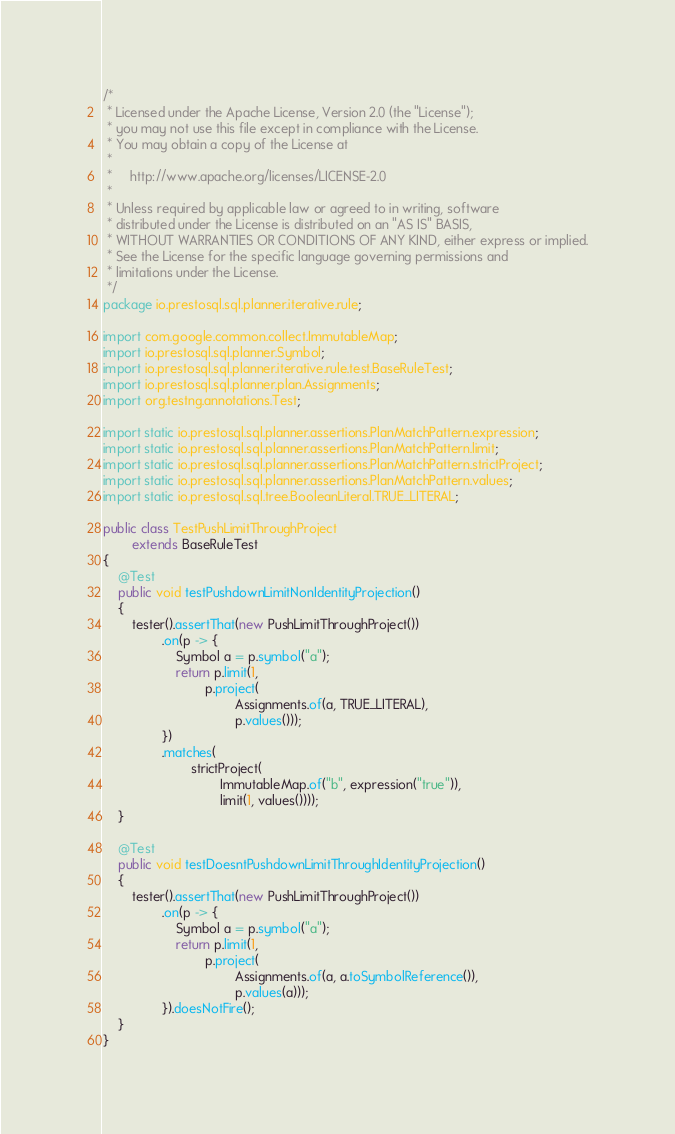Convert code to text. <code><loc_0><loc_0><loc_500><loc_500><_Java_>/*
 * Licensed under the Apache License, Version 2.0 (the "License");
 * you may not use this file except in compliance with the License.
 * You may obtain a copy of the License at
 *
 *     http://www.apache.org/licenses/LICENSE-2.0
 *
 * Unless required by applicable law or agreed to in writing, software
 * distributed under the License is distributed on an "AS IS" BASIS,
 * WITHOUT WARRANTIES OR CONDITIONS OF ANY KIND, either express or implied.
 * See the License for the specific language governing permissions and
 * limitations under the License.
 */
package io.prestosql.sql.planner.iterative.rule;

import com.google.common.collect.ImmutableMap;
import io.prestosql.sql.planner.Symbol;
import io.prestosql.sql.planner.iterative.rule.test.BaseRuleTest;
import io.prestosql.sql.planner.plan.Assignments;
import org.testng.annotations.Test;

import static io.prestosql.sql.planner.assertions.PlanMatchPattern.expression;
import static io.prestosql.sql.planner.assertions.PlanMatchPattern.limit;
import static io.prestosql.sql.planner.assertions.PlanMatchPattern.strictProject;
import static io.prestosql.sql.planner.assertions.PlanMatchPattern.values;
import static io.prestosql.sql.tree.BooleanLiteral.TRUE_LITERAL;

public class TestPushLimitThroughProject
        extends BaseRuleTest
{
    @Test
    public void testPushdownLimitNonIdentityProjection()
    {
        tester().assertThat(new PushLimitThroughProject())
                .on(p -> {
                    Symbol a = p.symbol("a");
                    return p.limit(1,
                            p.project(
                                    Assignments.of(a, TRUE_LITERAL),
                                    p.values()));
                })
                .matches(
                        strictProject(
                                ImmutableMap.of("b", expression("true")),
                                limit(1, values())));
    }

    @Test
    public void testDoesntPushdownLimitThroughIdentityProjection()
    {
        tester().assertThat(new PushLimitThroughProject())
                .on(p -> {
                    Symbol a = p.symbol("a");
                    return p.limit(1,
                            p.project(
                                    Assignments.of(a, a.toSymbolReference()),
                                    p.values(a)));
                }).doesNotFire();
    }
}
</code> 